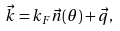<formula> <loc_0><loc_0><loc_500><loc_500>\vec { k } = k _ { F } \vec { n } ( \theta ) + \vec { q } ,</formula> 